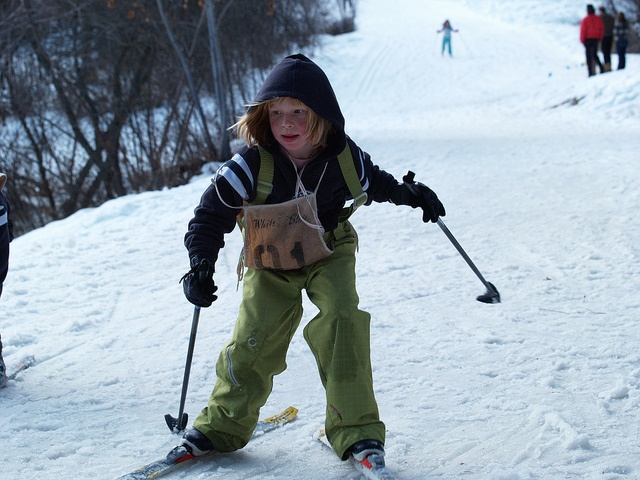Describe the objects in this image and their specific colors. I can see people in black, gray, and darkgreen tones, skis in black, gray, and darkgray tones, people in black, brown, and maroon tones, people in black, gray, and blue tones, and people in black, gray, and darkblue tones in this image. 